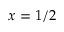Convert formula to latex. <formula><loc_0><loc_0><loc_500><loc_500>x = 1 / 2</formula> 